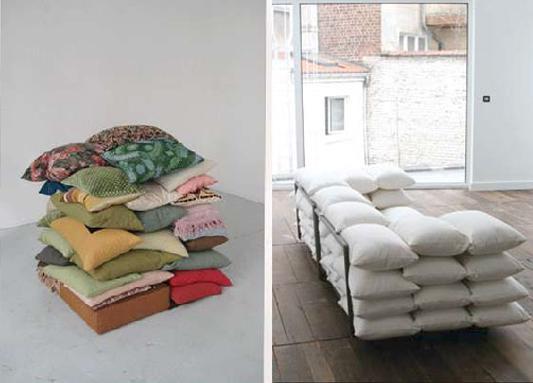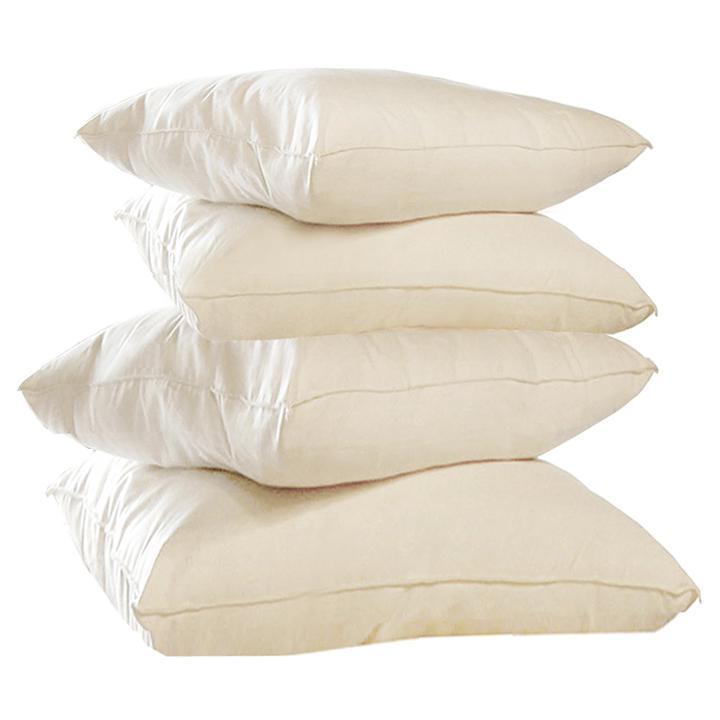The first image is the image on the left, the second image is the image on the right. Analyze the images presented: Is the assertion "In one image, pillows are stacked five across to form a couch-like seating area." valid? Answer yes or no. Yes. 